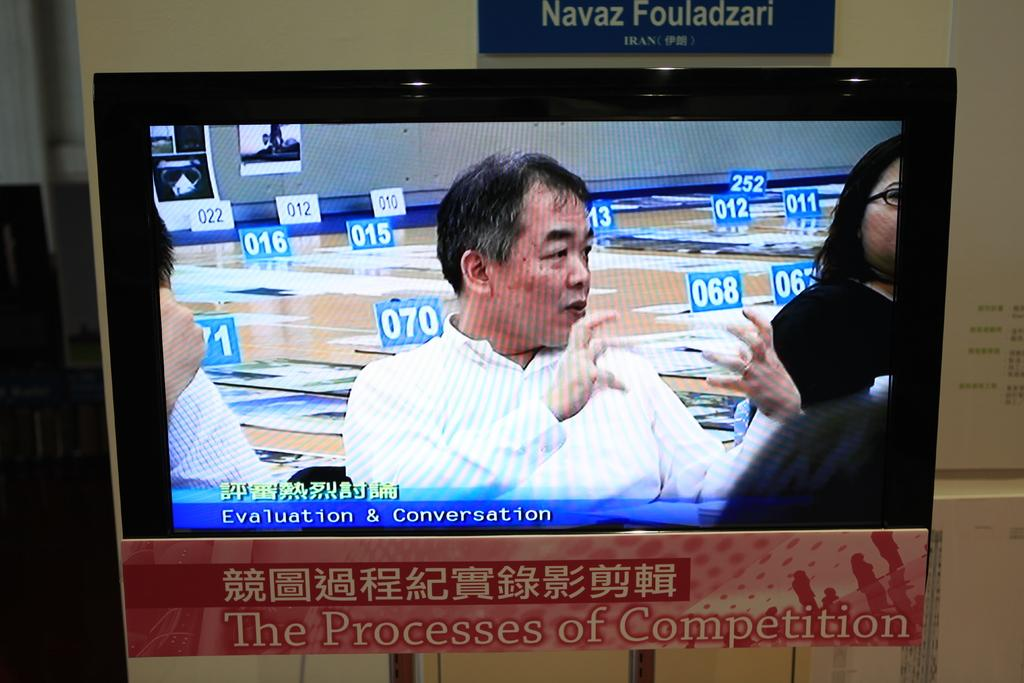Provide a one-sentence caption for the provided image. A man on a monitor is seen above the words Evaluation & Conversation. 